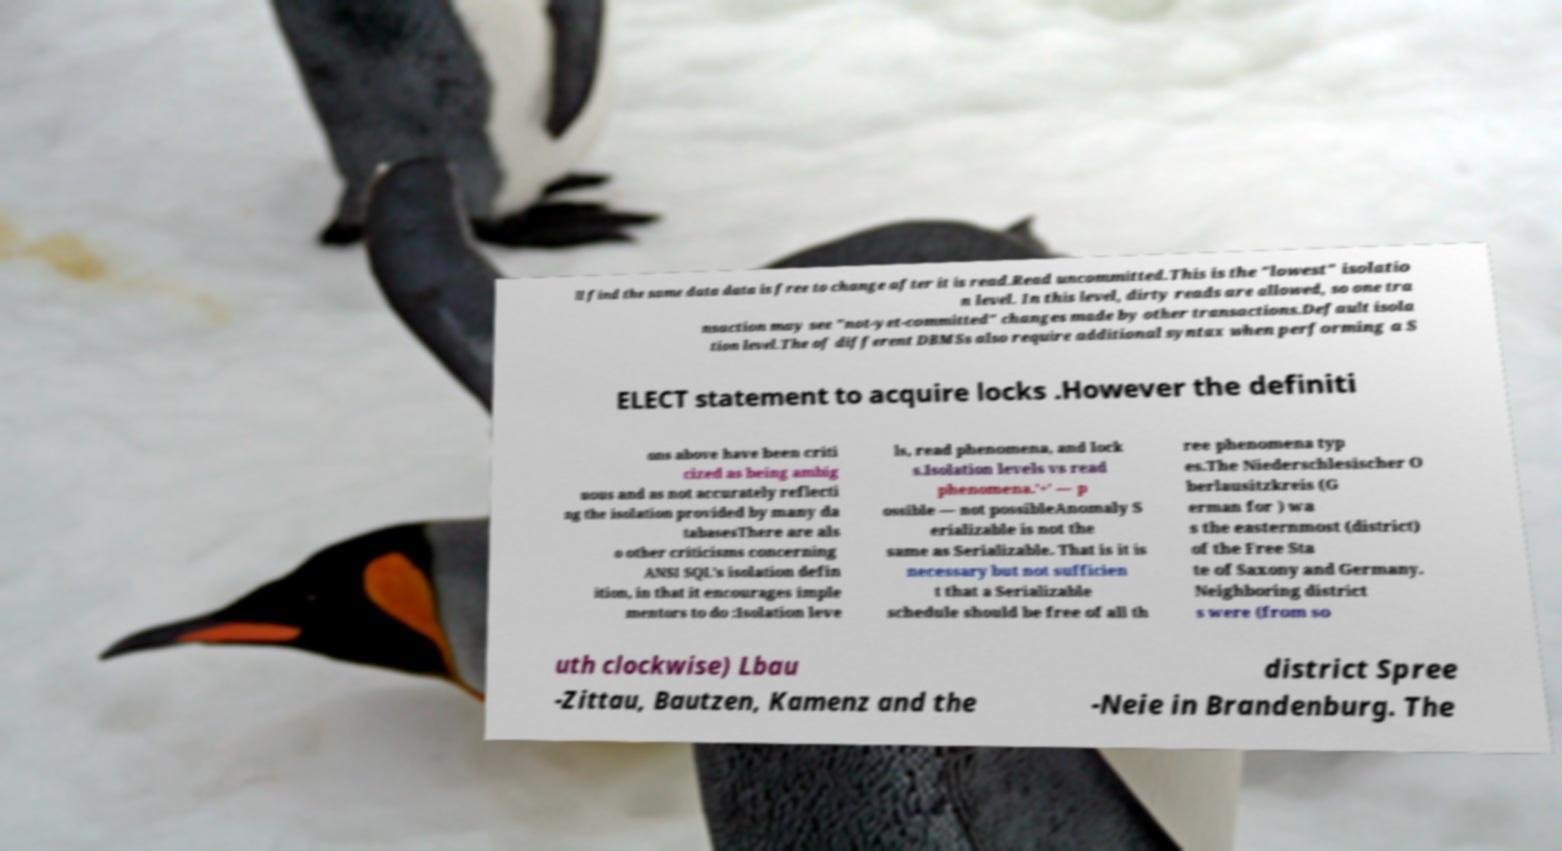What messages or text are displayed in this image? I need them in a readable, typed format. ll find the same data data is free to change after it is read.Read uncommitted.This is the "lowest" isolatio n level. In this level, dirty reads are allowed, so one tra nsaction may see "not-yet-committed" changes made by other transactions.Default isola tion level.The of different DBMSs also require additional syntax when performing a S ELECT statement to acquire locks .However the definiti ons above have been criti cized as being ambig uous and as not accurately reflecti ng the isolation provided by many da tabasesThere are als o other criticisms concerning ANSI SQL's isolation defin ition, in that it encourages imple mentors to do :Isolation leve ls, read phenomena, and lock s.Isolation levels vs read phenomena.'+' — p ossible — not possibleAnomaly S erializable is not the same as Serializable. That is it is necessary but not sufficien t that a Serializable schedule should be free of all th ree phenomena typ es.The Niederschlesischer O berlausitzkreis (G erman for ) wa s the easternmost (district) of the Free Sta te of Saxony and Germany. Neighboring district s were (from so uth clockwise) Lbau -Zittau, Bautzen, Kamenz and the district Spree -Neie in Brandenburg. The 